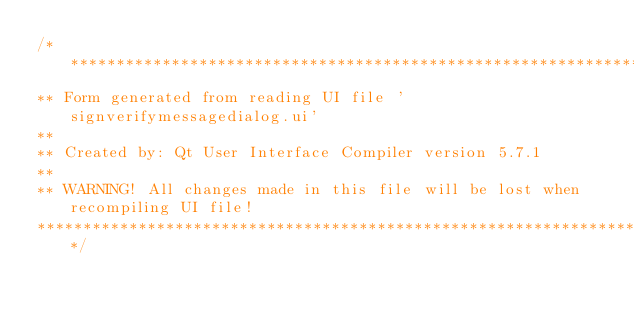<code> <loc_0><loc_0><loc_500><loc_500><_C_>/********************************************************************************
** Form generated from reading UI file 'signverifymessagedialog.ui'
**
** Created by: Qt User Interface Compiler version 5.7.1
**
** WARNING! All changes made in this file will be lost when recompiling UI file!
********************************************************************************/
</code> 